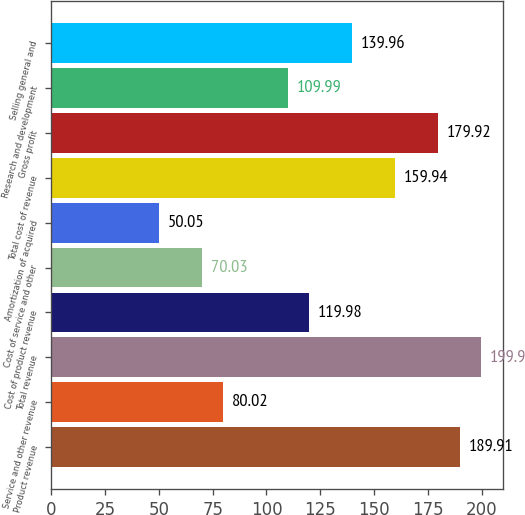<chart> <loc_0><loc_0><loc_500><loc_500><bar_chart><fcel>Product revenue<fcel>Service and other revenue<fcel>Total revenue<fcel>Cost of product revenue<fcel>Cost of service and other<fcel>Amortization of acquired<fcel>Total cost of revenue<fcel>Gross profit<fcel>Research and development<fcel>Selling general and<nl><fcel>189.91<fcel>80.02<fcel>199.9<fcel>119.98<fcel>70.03<fcel>50.05<fcel>159.94<fcel>179.92<fcel>109.99<fcel>139.96<nl></chart> 